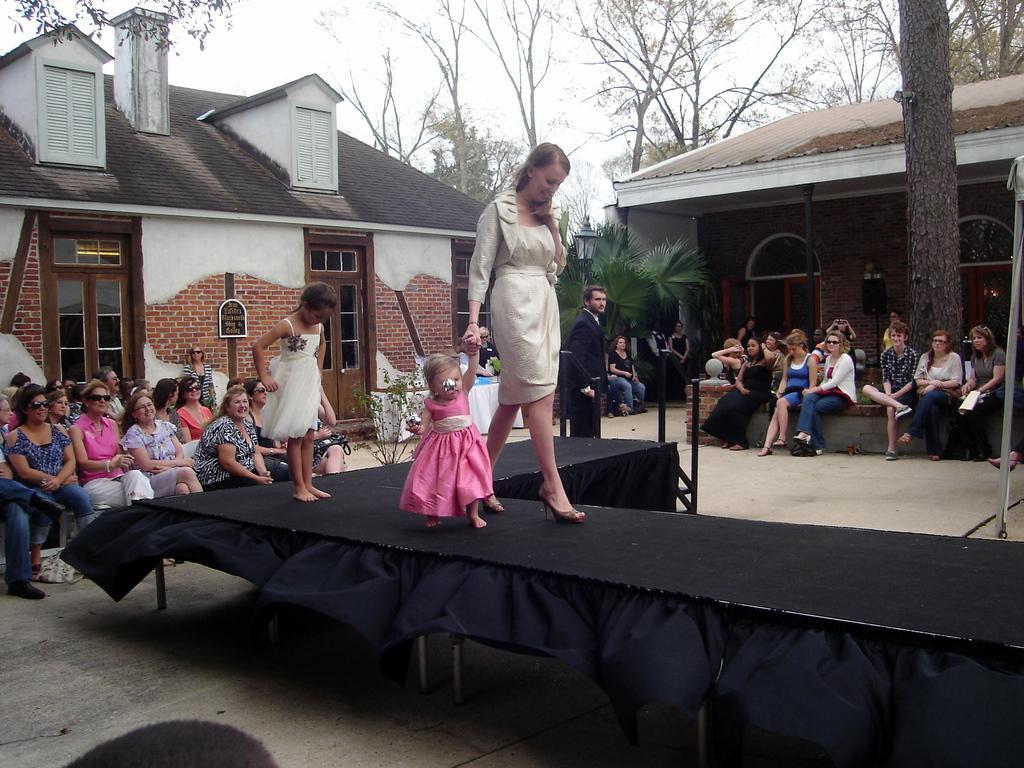Can you describe this image briefly? In this image there are many people sitting on the chairs. In the center there is a ramp. On the ramp there is a woman and two kids walking. In the background there are houses, trees and street light poles. At the top there is a sky. Beside the ramp there is a man standing. 